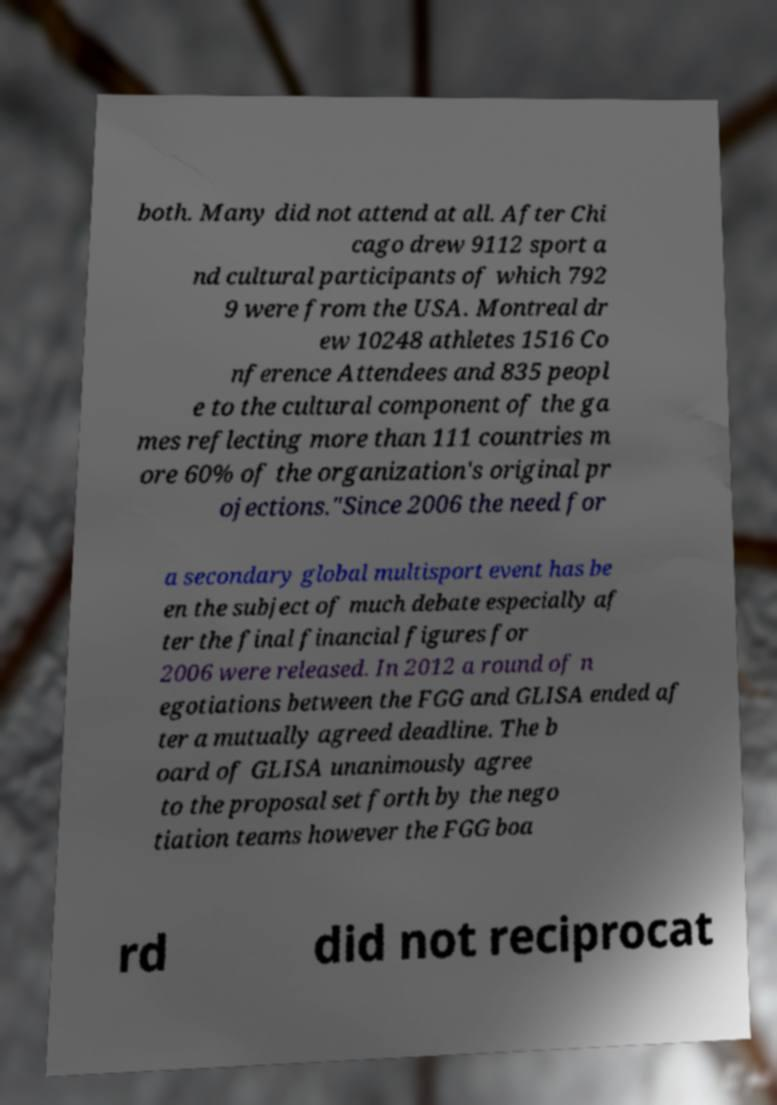I need the written content from this picture converted into text. Can you do that? both. Many did not attend at all. After Chi cago drew 9112 sport a nd cultural participants of which 792 9 were from the USA. Montreal dr ew 10248 athletes 1516 Co nference Attendees and 835 peopl e to the cultural component of the ga mes reflecting more than 111 countries m ore 60% of the organization's original pr ojections."Since 2006 the need for a secondary global multisport event has be en the subject of much debate especially af ter the final financial figures for 2006 were released. In 2012 a round of n egotiations between the FGG and GLISA ended af ter a mutually agreed deadline. The b oard of GLISA unanimously agree to the proposal set forth by the nego tiation teams however the FGG boa rd did not reciprocat 